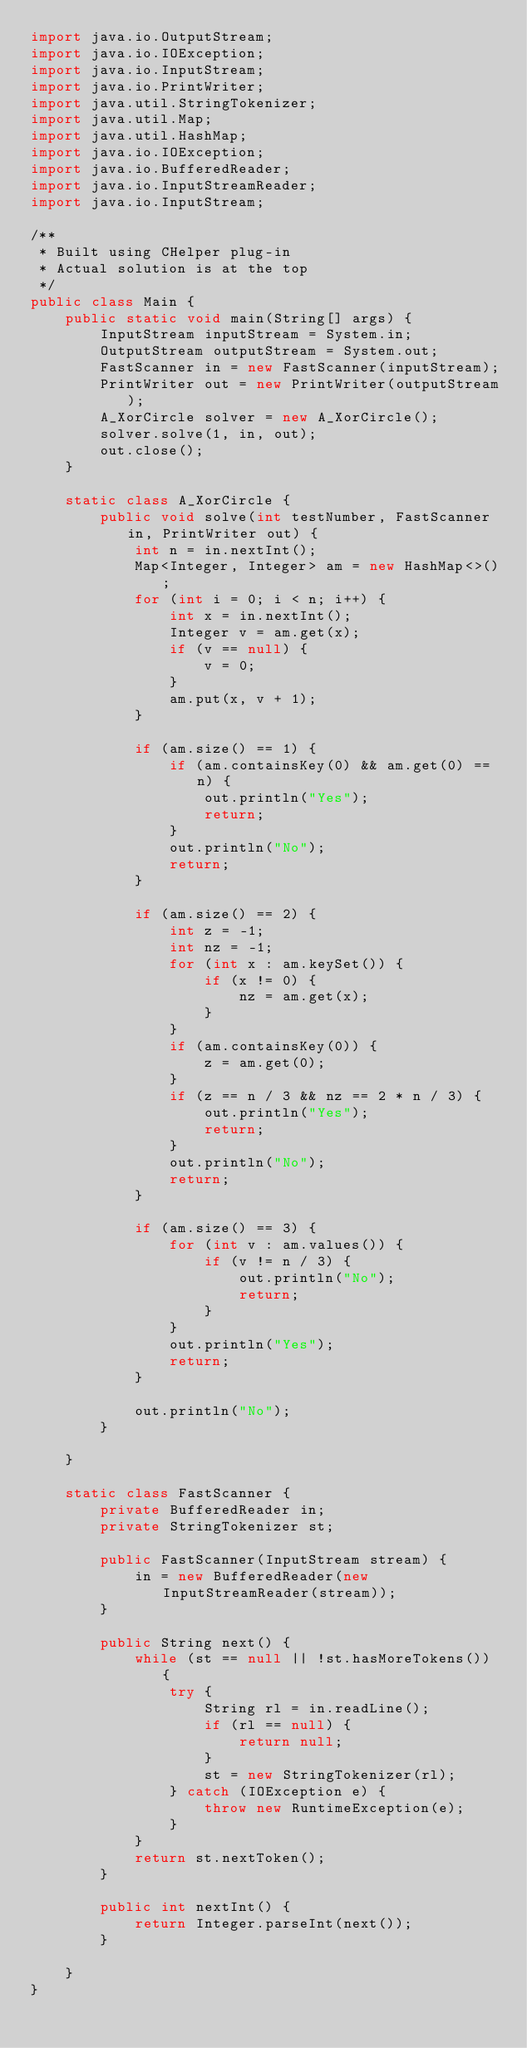<code> <loc_0><loc_0><loc_500><loc_500><_Java_>import java.io.OutputStream;
import java.io.IOException;
import java.io.InputStream;
import java.io.PrintWriter;
import java.util.StringTokenizer;
import java.util.Map;
import java.util.HashMap;
import java.io.IOException;
import java.io.BufferedReader;
import java.io.InputStreamReader;
import java.io.InputStream;

/**
 * Built using CHelper plug-in
 * Actual solution is at the top
 */
public class Main {
    public static void main(String[] args) {
        InputStream inputStream = System.in;
        OutputStream outputStream = System.out;
        FastScanner in = new FastScanner(inputStream);
        PrintWriter out = new PrintWriter(outputStream);
        A_XorCircle solver = new A_XorCircle();
        solver.solve(1, in, out);
        out.close();
    }

    static class A_XorCircle {
        public void solve(int testNumber, FastScanner in, PrintWriter out) {
            int n = in.nextInt();
            Map<Integer, Integer> am = new HashMap<>();
            for (int i = 0; i < n; i++) {
                int x = in.nextInt();
                Integer v = am.get(x);
                if (v == null) {
                    v = 0;
                }
                am.put(x, v + 1);
            }

            if (am.size() == 1) {
                if (am.containsKey(0) && am.get(0) == n) {
                    out.println("Yes");
                    return;
                }
                out.println("No");
                return;
            }

            if (am.size() == 2) {
                int z = -1;
                int nz = -1;
                for (int x : am.keySet()) {
                    if (x != 0) {
                        nz = am.get(x);
                    }
                }
                if (am.containsKey(0)) {
                    z = am.get(0);
                }
                if (z == n / 3 && nz == 2 * n / 3) {
                    out.println("Yes");
                    return;
                }
                out.println("No");
                return;
            }

            if (am.size() == 3) {
                for (int v : am.values()) {
                    if (v != n / 3) {
                        out.println("No");
                        return;
                    }
                }
                out.println("Yes");
                return;
            }

            out.println("No");
        }

    }

    static class FastScanner {
        private BufferedReader in;
        private StringTokenizer st;

        public FastScanner(InputStream stream) {
            in = new BufferedReader(new InputStreamReader(stream));
        }

        public String next() {
            while (st == null || !st.hasMoreTokens()) {
                try {
                    String rl = in.readLine();
                    if (rl == null) {
                        return null;
                    }
                    st = new StringTokenizer(rl);
                } catch (IOException e) {
                    throw new RuntimeException(e);
                }
            }
            return st.nextToken();
        }

        public int nextInt() {
            return Integer.parseInt(next());
        }

    }
}

</code> 